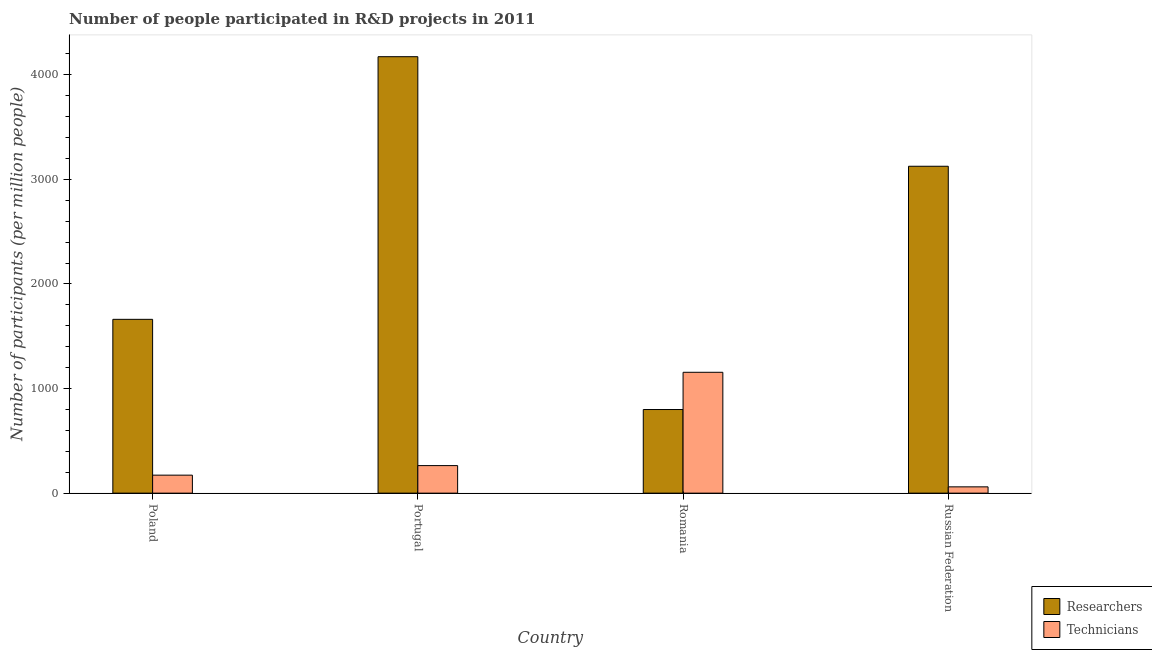How many different coloured bars are there?
Keep it short and to the point. 2. In how many cases, is the number of bars for a given country not equal to the number of legend labels?
Offer a terse response. 0. What is the number of technicians in Portugal?
Keep it short and to the point. 263.36. Across all countries, what is the maximum number of technicians?
Ensure brevity in your answer.  1155.52. Across all countries, what is the minimum number of researchers?
Provide a short and direct response. 799.54. In which country was the number of technicians maximum?
Provide a short and direct response. Romania. In which country was the number of researchers minimum?
Offer a very short reply. Romania. What is the total number of researchers in the graph?
Your response must be concise. 9759.42. What is the difference between the number of researchers in Portugal and that in Russian Federation?
Give a very brief answer. 1047.56. What is the difference between the number of technicians in Poland and the number of researchers in Romania?
Offer a terse response. -627.46. What is the average number of technicians per country?
Offer a terse response. 412.78. What is the difference between the number of researchers and number of technicians in Romania?
Offer a very short reply. -355.99. What is the ratio of the number of technicians in Portugal to that in Romania?
Your response must be concise. 0.23. Is the difference between the number of researchers in Poland and Romania greater than the difference between the number of technicians in Poland and Romania?
Offer a terse response. Yes. What is the difference between the highest and the second highest number of researchers?
Offer a terse response. 1047.56. What is the difference between the highest and the lowest number of technicians?
Offer a very short reply. 1095.36. Is the sum of the number of researchers in Poland and Russian Federation greater than the maximum number of technicians across all countries?
Give a very brief answer. Yes. What does the 1st bar from the left in Romania represents?
Give a very brief answer. Researchers. What does the 2nd bar from the right in Romania represents?
Provide a short and direct response. Researchers. How many bars are there?
Your response must be concise. 8. How many countries are there in the graph?
Make the answer very short. 4. What is the difference between two consecutive major ticks on the Y-axis?
Your answer should be compact. 1000. Does the graph contain any zero values?
Make the answer very short. No. Does the graph contain grids?
Make the answer very short. No. How are the legend labels stacked?
Your response must be concise. Vertical. What is the title of the graph?
Keep it short and to the point. Number of people participated in R&D projects in 2011. Does "Net savings(excluding particulate emission damage)" appear as one of the legend labels in the graph?
Ensure brevity in your answer.  No. What is the label or title of the Y-axis?
Ensure brevity in your answer.  Number of participants (per million people). What is the Number of participants (per million people) in Researchers in Poland?
Your response must be concise. 1661.72. What is the Number of participants (per million people) in Technicians in Poland?
Your answer should be very brief. 172.08. What is the Number of participants (per million people) of Researchers in Portugal?
Give a very brief answer. 4172.86. What is the Number of participants (per million people) in Technicians in Portugal?
Make the answer very short. 263.36. What is the Number of participants (per million people) in Researchers in Romania?
Ensure brevity in your answer.  799.54. What is the Number of participants (per million people) in Technicians in Romania?
Offer a terse response. 1155.52. What is the Number of participants (per million people) of Researchers in Russian Federation?
Your answer should be compact. 3125.3. What is the Number of participants (per million people) of Technicians in Russian Federation?
Offer a very short reply. 60.16. Across all countries, what is the maximum Number of participants (per million people) of Researchers?
Ensure brevity in your answer.  4172.86. Across all countries, what is the maximum Number of participants (per million people) in Technicians?
Offer a very short reply. 1155.52. Across all countries, what is the minimum Number of participants (per million people) of Researchers?
Ensure brevity in your answer.  799.54. Across all countries, what is the minimum Number of participants (per million people) in Technicians?
Provide a short and direct response. 60.16. What is the total Number of participants (per million people) of Researchers in the graph?
Your answer should be compact. 9759.42. What is the total Number of participants (per million people) of Technicians in the graph?
Provide a succinct answer. 1651.12. What is the difference between the Number of participants (per million people) of Researchers in Poland and that in Portugal?
Your response must be concise. -2511.14. What is the difference between the Number of participants (per million people) in Technicians in Poland and that in Portugal?
Give a very brief answer. -91.28. What is the difference between the Number of participants (per million people) in Researchers in Poland and that in Romania?
Give a very brief answer. 862.18. What is the difference between the Number of participants (per million people) of Technicians in Poland and that in Romania?
Offer a very short reply. -983.45. What is the difference between the Number of participants (per million people) of Researchers in Poland and that in Russian Federation?
Your answer should be very brief. -1463.58. What is the difference between the Number of participants (per million people) of Technicians in Poland and that in Russian Federation?
Your answer should be very brief. 111.92. What is the difference between the Number of participants (per million people) of Researchers in Portugal and that in Romania?
Keep it short and to the point. 3373.33. What is the difference between the Number of participants (per million people) in Technicians in Portugal and that in Romania?
Make the answer very short. -892.16. What is the difference between the Number of participants (per million people) in Researchers in Portugal and that in Russian Federation?
Offer a terse response. 1047.56. What is the difference between the Number of participants (per million people) in Technicians in Portugal and that in Russian Federation?
Offer a terse response. 203.2. What is the difference between the Number of participants (per million people) of Researchers in Romania and that in Russian Federation?
Ensure brevity in your answer.  -2325.77. What is the difference between the Number of participants (per million people) in Technicians in Romania and that in Russian Federation?
Keep it short and to the point. 1095.36. What is the difference between the Number of participants (per million people) of Researchers in Poland and the Number of participants (per million people) of Technicians in Portugal?
Give a very brief answer. 1398.36. What is the difference between the Number of participants (per million people) in Researchers in Poland and the Number of participants (per million people) in Technicians in Romania?
Provide a succinct answer. 506.2. What is the difference between the Number of participants (per million people) in Researchers in Poland and the Number of participants (per million people) in Technicians in Russian Federation?
Provide a succinct answer. 1601.56. What is the difference between the Number of participants (per million people) of Researchers in Portugal and the Number of participants (per million people) of Technicians in Romania?
Make the answer very short. 3017.34. What is the difference between the Number of participants (per million people) in Researchers in Portugal and the Number of participants (per million people) in Technicians in Russian Federation?
Give a very brief answer. 4112.71. What is the difference between the Number of participants (per million people) of Researchers in Romania and the Number of participants (per million people) of Technicians in Russian Federation?
Offer a terse response. 739.38. What is the average Number of participants (per million people) in Researchers per country?
Your answer should be compact. 2439.86. What is the average Number of participants (per million people) in Technicians per country?
Make the answer very short. 412.78. What is the difference between the Number of participants (per million people) in Researchers and Number of participants (per million people) in Technicians in Poland?
Provide a succinct answer. 1489.64. What is the difference between the Number of participants (per million people) of Researchers and Number of participants (per million people) of Technicians in Portugal?
Provide a succinct answer. 3909.5. What is the difference between the Number of participants (per million people) of Researchers and Number of participants (per million people) of Technicians in Romania?
Give a very brief answer. -355.99. What is the difference between the Number of participants (per million people) in Researchers and Number of participants (per million people) in Technicians in Russian Federation?
Provide a succinct answer. 3065.14. What is the ratio of the Number of participants (per million people) of Researchers in Poland to that in Portugal?
Make the answer very short. 0.4. What is the ratio of the Number of participants (per million people) in Technicians in Poland to that in Portugal?
Provide a short and direct response. 0.65. What is the ratio of the Number of participants (per million people) of Researchers in Poland to that in Romania?
Your answer should be compact. 2.08. What is the ratio of the Number of participants (per million people) of Technicians in Poland to that in Romania?
Your answer should be very brief. 0.15. What is the ratio of the Number of participants (per million people) of Researchers in Poland to that in Russian Federation?
Keep it short and to the point. 0.53. What is the ratio of the Number of participants (per million people) of Technicians in Poland to that in Russian Federation?
Make the answer very short. 2.86. What is the ratio of the Number of participants (per million people) in Researchers in Portugal to that in Romania?
Your answer should be compact. 5.22. What is the ratio of the Number of participants (per million people) in Technicians in Portugal to that in Romania?
Offer a very short reply. 0.23. What is the ratio of the Number of participants (per million people) of Researchers in Portugal to that in Russian Federation?
Ensure brevity in your answer.  1.34. What is the ratio of the Number of participants (per million people) in Technicians in Portugal to that in Russian Federation?
Your answer should be very brief. 4.38. What is the ratio of the Number of participants (per million people) in Researchers in Romania to that in Russian Federation?
Provide a short and direct response. 0.26. What is the ratio of the Number of participants (per million people) of Technicians in Romania to that in Russian Federation?
Your response must be concise. 19.21. What is the difference between the highest and the second highest Number of participants (per million people) in Researchers?
Your answer should be compact. 1047.56. What is the difference between the highest and the second highest Number of participants (per million people) in Technicians?
Your answer should be very brief. 892.16. What is the difference between the highest and the lowest Number of participants (per million people) in Researchers?
Provide a short and direct response. 3373.33. What is the difference between the highest and the lowest Number of participants (per million people) of Technicians?
Your response must be concise. 1095.36. 